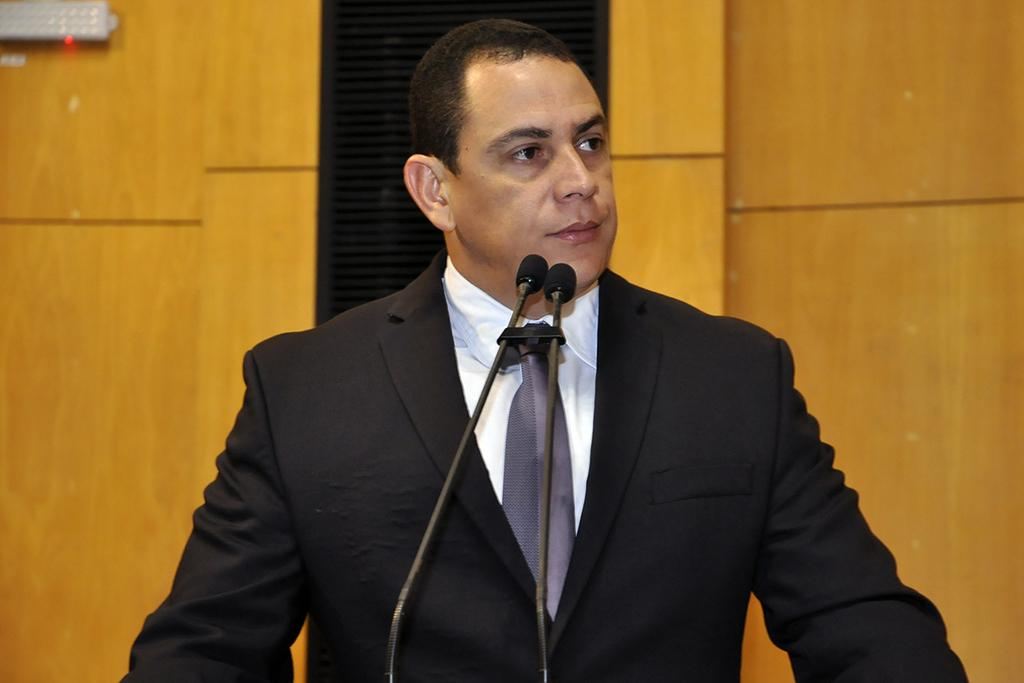Who is the main subject in the image? There is a man in the image. What is the man wearing? The man is wearing a blazer and a tie. What objects are in front of the man? There are microphones in front of the man. What can be seen in the background of the image? There is a wall in the background of the image. Can you tell me how many cacti are on the man's tie in the image? There are no cacti present on the man's tie in the image. What type of lumber is being used to construct the wall in the background? There is no information about the construction of the wall in the image, and no lumber is visible. 